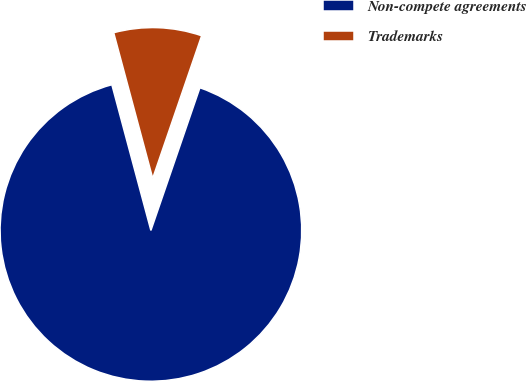<chart> <loc_0><loc_0><loc_500><loc_500><pie_chart><fcel>Non-compete agreements<fcel>Trademarks<nl><fcel>90.57%<fcel>9.43%<nl></chart> 